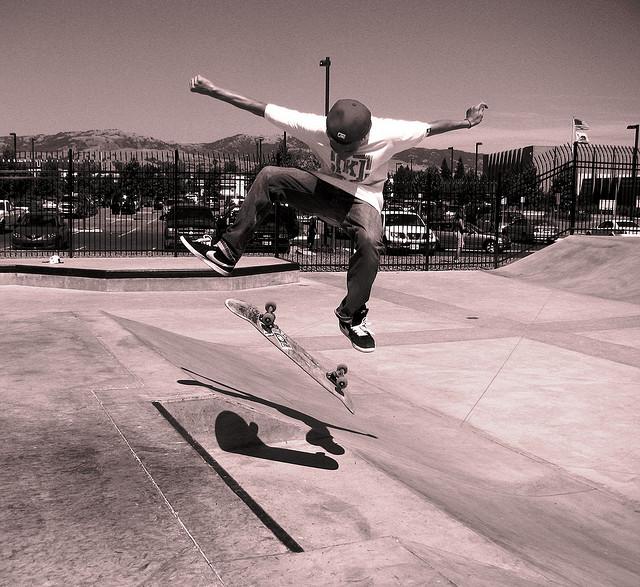Which direction are the wheels pointed?
Keep it brief. Up. Is the boy skating in a designated skating area?
Short answer required. Yes. Is the man going to stick the landing?
Short answer required. Yes. 